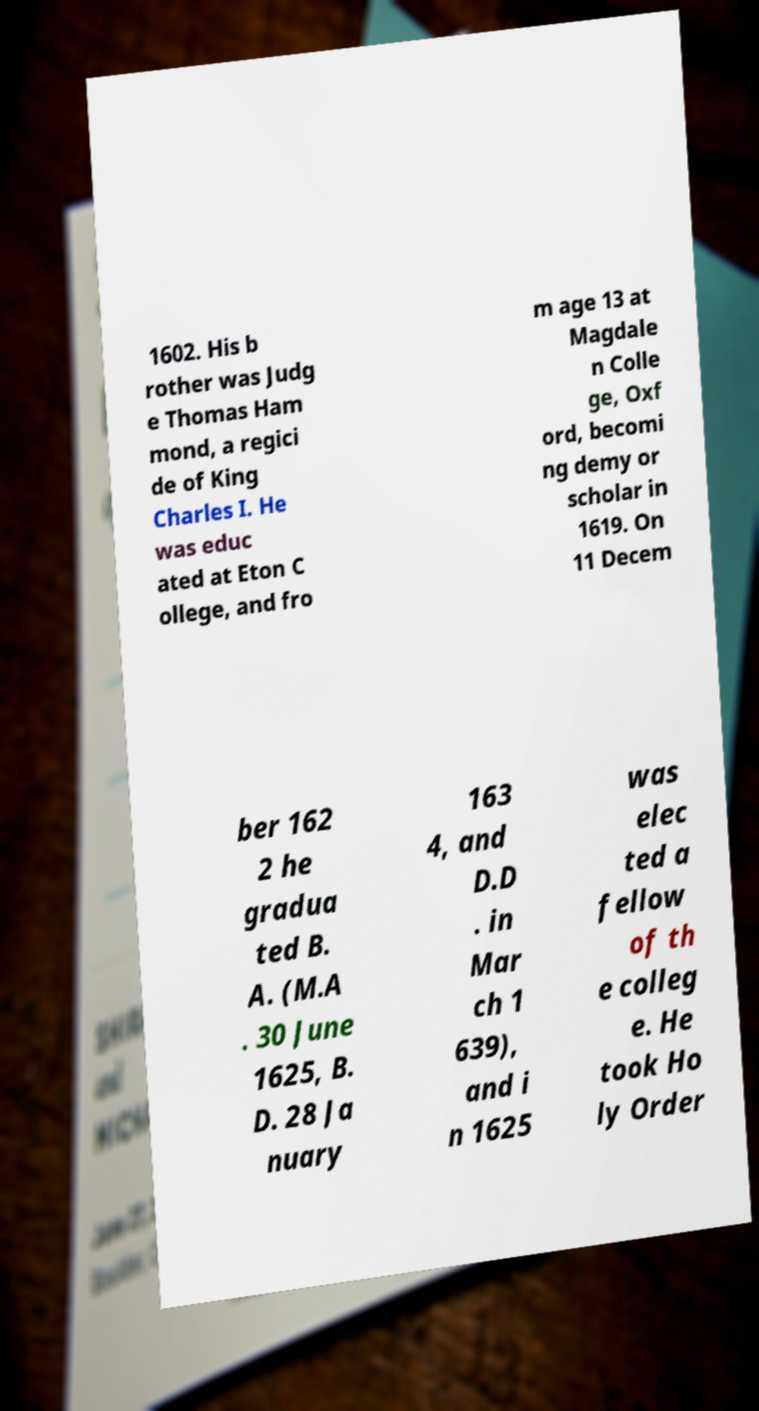Can you read and provide the text displayed in the image?This photo seems to have some interesting text. Can you extract and type it out for me? 1602. His b rother was Judg e Thomas Ham mond, a regici de of King Charles I. He was educ ated at Eton C ollege, and fro m age 13 at Magdale n Colle ge, Oxf ord, becomi ng demy or scholar in 1619. On 11 Decem ber 162 2 he gradua ted B. A. (M.A . 30 June 1625, B. D. 28 Ja nuary 163 4, and D.D . in Mar ch 1 639), and i n 1625 was elec ted a fellow of th e colleg e. He took Ho ly Order 